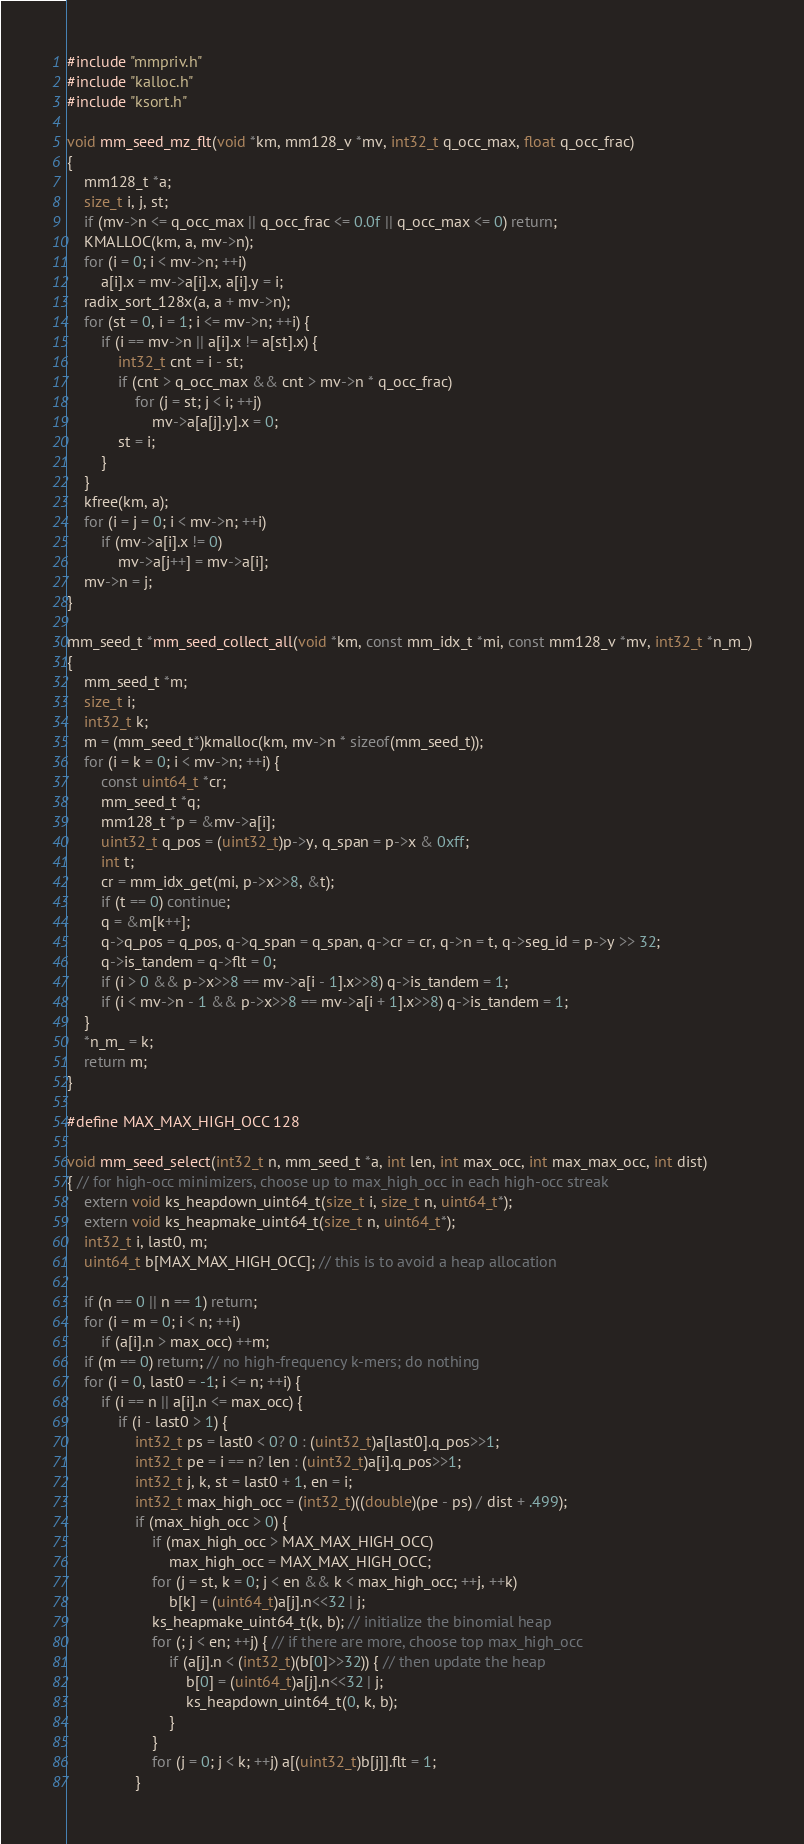Convert code to text. <code><loc_0><loc_0><loc_500><loc_500><_C_>#include "mmpriv.h"
#include "kalloc.h"
#include "ksort.h"

void mm_seed_mz_flt(void *km, mm128_v *mv, int32_t q_occ_max, float q_occ_frac)
{
	mm128_t *a;
	size_t i, j, st;
	if (mv->n <= q_occ_max || q_occ_frac <= 0.0f || q_occ_max <= 0) return;
	KMALLOC(km, a, mv->n);
	for (i = 0; i < mv->n; ++i)
		a[i].x = mv->a[i].x, a[i].y = i;
	radix_sort_128x(a, a + mv->n);
	for (st = 0, i = 1; i <= mv->n; ++i) {
		if (i == mv->n || a[i].x != a[st].x) {
			int32_t cnt = i - st;
			if (cnt > q_occ_max && cnt > mv->n * q_occ_frac)
				for (j = st; j < i; ++j)
					mv->a[a[j].y].x = 0;
			st = i;
		}
	}
	kfree(km, a);
	for (i = j = 0; i < mv->n; ++i)
		if (mv->a[i].x != 0)
			mv->a[j++] = mv->a[i];
	mv->n = j;
}

mm_seed_t *mm_seed_collect_all(void *km, const mm_idx_t *mi, const mm128_v *mv, int32_t *n_m_)
{
	mm_seed_t *m;
	size_t i;
	int32_t k;
	m = (mm_seed_t*)kmalloc(km, mv->n * sizeof(mm_seed_t));
	for (i = k = 0; i < mv->n; ++i) {
		const uint64_t *cr;
		mm_seed_t *q;
		mm128_t *p = &mv->a[i];
		uint32_t q_pos = (uint32_t)p->y, q_span = p->x & 0xff;
		int t;
		cr = mm_idx_get(mi, p->x>>8, &t);
		if (t == 0) continue;
		q = &m[k++];
		q->q_pos = q_pos, q->q_span = q_span, q->cr = cr, q->n = t, q->seg_id = p->y >> 32;
		q->is_tandem = q->flt = 0;
		if (i > 0 && p->x>>8 == mv->a[i - 1].x>>8) q->is_tandem = 1;
		if (i < mv->n - 1 && p->x>>8 == mv->a[i + 1].x>>8) q->is_tandem = 1;
	}
	*n_m_ = k;
	return m;
}

#define MAX_MAX_HIGH_OCC 128

void mm_seed_select(int32_t n, mm_seed_t *a, int len, int max_occ, int max_max_occ, int dist)
{ // for high-occ minimizers, choose up to max_high_occ in each high-occ streak
	extern void ks_heapdown_uint64_t(size_t i, size_t n, uint64_t*);
	extern void ks_heapmake_uint64_t(size_t n, uint64_t*);
	int32_t i, last0, m;
	uint64_t b[MAX_MAX_HIGH_OCC]; // this is to avoid a heap allocation

	if (n == 0 || n == 1) return;
	for (i = m = 0; i < n; ++i)
		if (a[i].n > max_occ) ++m;
	if (m == 0) return; // no high-frequency k-mers; do nothing
	for (i = 0, last0 = -1; i <= n; ++i) {
		if (i == n || a[i].n <= max_occ) {
			if (i - last0 > 1) {
				int32_t ps = last0 < 0? 0 : (uint32_t)a[last0].q_pos>>1;
				int32_t pe = i == n? len : (uint32_t)a[i].q_pos>>1;
				int32_t j, k, st = last0 + 1, en = i;
				int32_t max_high_occ = (int32_t)((double)(pe - ps) / dist + .499);
				if (max_high_occ > 0) {
					if (max_high_occ > MAX_MAX_HIGH_OCC)
						max_high_occ = MAX_MAX_HIGH_OCC;
					for (j = st, k = 0; j < en && k < max_high_occ; ++j, ++k)
						b[k] = (uint64_t)a[j].n<<32 | j;
					ks_heapmake_uint64_t(k, b); // initialize the binomial heap
					for (; j < en; ++j) { // if there are more, choose top max_high_occ
						if (a[j].n < (int32_t)(b[0]>>32)) { // then update the heap
							b[0] = (uint64_t)a[j].n<<32 | j;
							ks_heapdown_uint64_t(0, k, b);
						}
					}
					for (j = 0; j < k; ++j) a[(uint32_t)b[j]].flt = 1;
				}</code> 